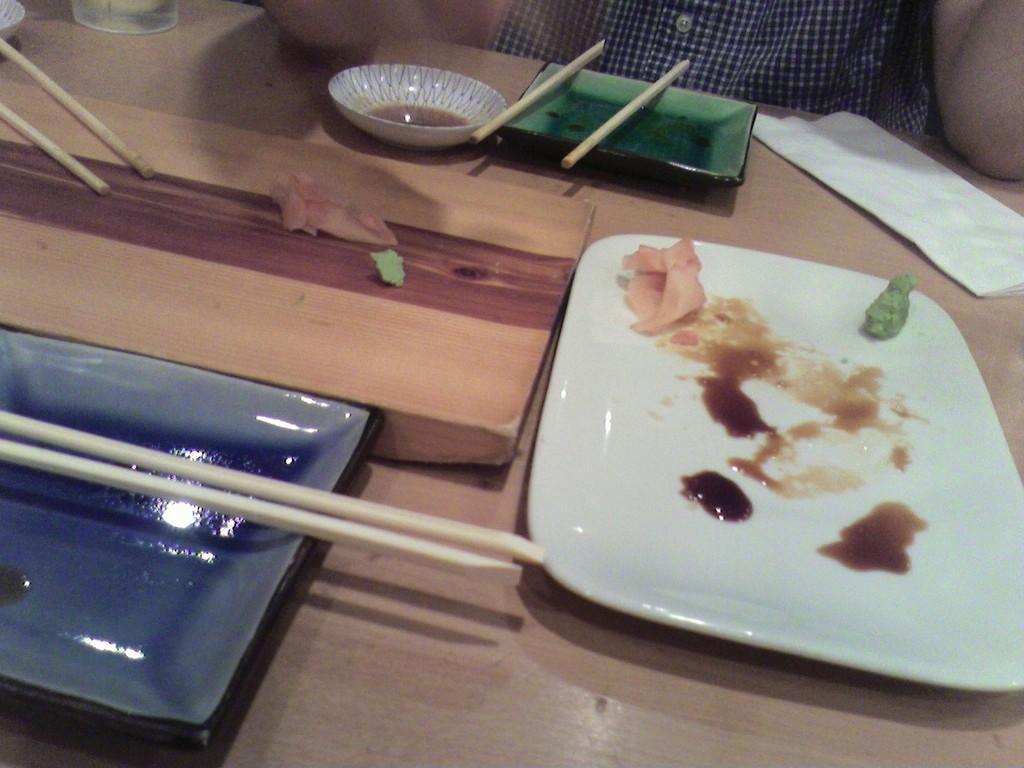How would you summarize this image in a sentence or two? there is an empty plate with leftover food and a bowl, chopsticks with the tissue on a table 